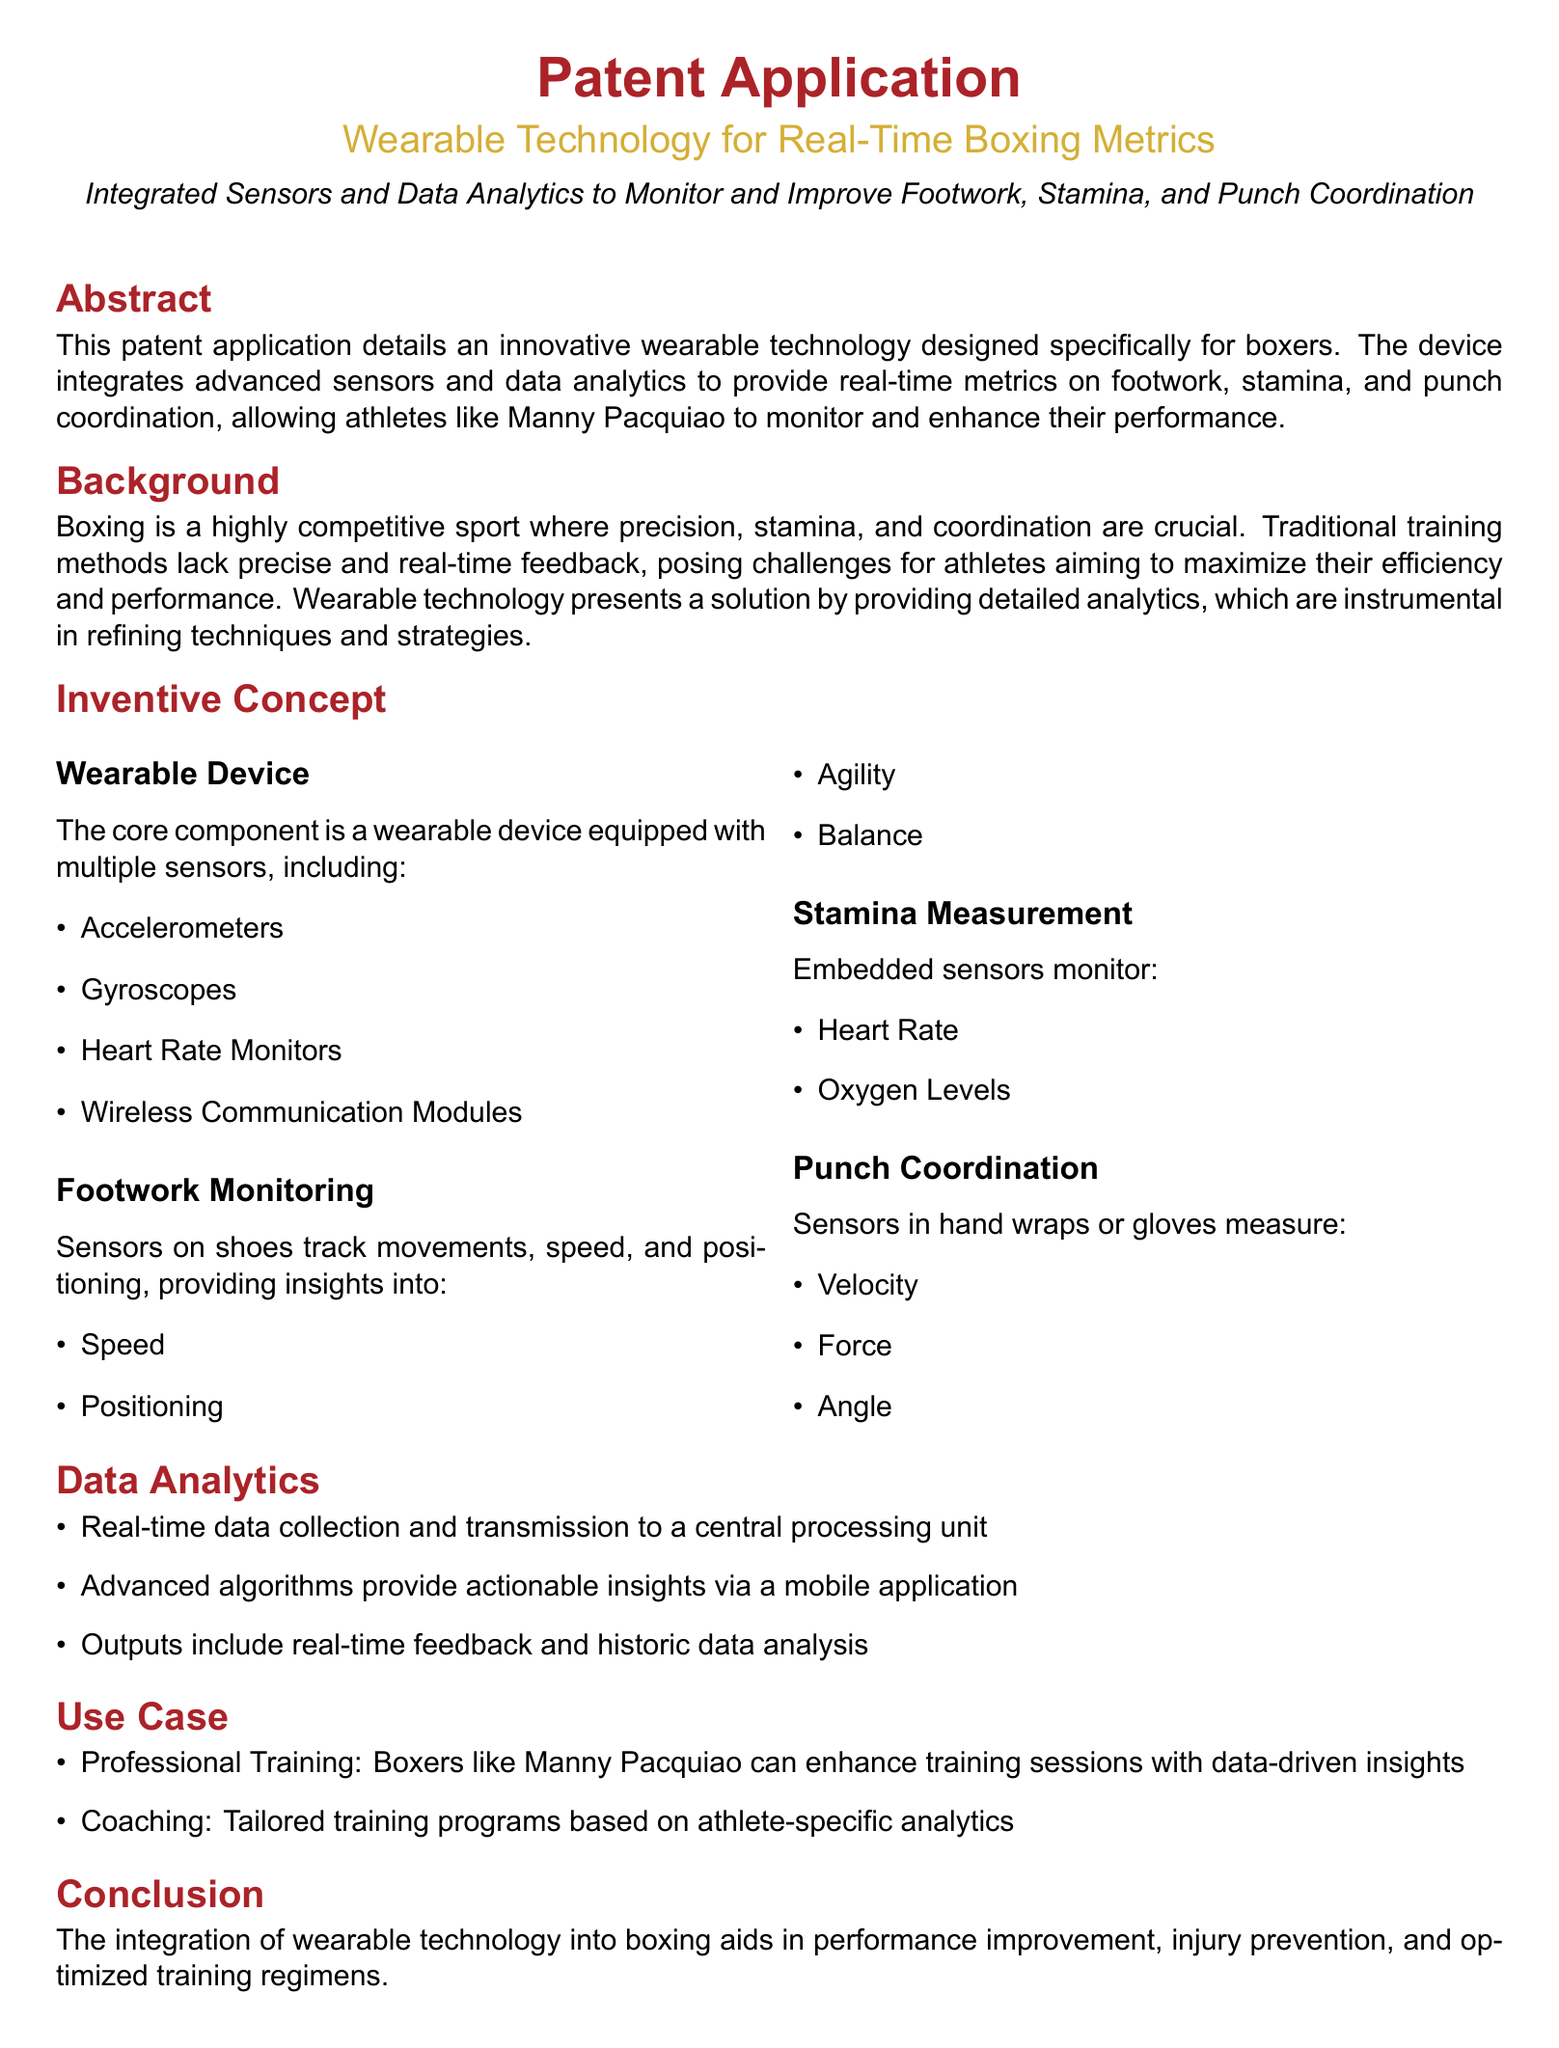What is the main purpose of the patent application? The purpose of the patent application is to detail an innovative wearable technology designed specifically for boxers.
Answer: wearable technology for boxers Which boxer is mentioned as a potential user of the device? The document mentions Manny Pacquiao as a potential user of the device.
Answer: Manny Pacquiao What integrated sensors are included in the wearable device? The sensors include accelerometers, gyroscopes, heart rate monitors, and wireless communication modules.
Answer: accelerometers, gyroscopes, heart rate monitors, wireless communication modules What does the footwork monitoring section track? The footwork monitoring section tracks movements, speed, and positioning.
Answer: movements, speed, positioning How is punch coordination measured? Punch coordination is measured using sensors in hand wraps or gloves.
Answer: sensors in hand wraps or gloves What type of data analytics does the device provide? The device provides real-time data collection and advanced algorithms.
Answer: real-time data collection and advanced algorithms What benefit does the device offer for coaching? The device offers tailored training programs based on athlete-specific analytics.
Answer: tailored training programs What are the two main claims made in the patent? The claims involve a wearable device for monitoring footwork, stamina, and punch coordination, and immediate feedback with data analysis for performance improvement.
Answer: monitoring footwork, stamina, punch coordination; immediate feedback and data analysis How does the device aid in performance improvement? The device aids in performance improvement by integrating wearable technology into boxing.
Answer: integrating wearable technology into boxing 